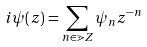<formula> <loc_0><loc_0><loc_500><loc_500>i \psi ( z ) = \sum _ { n \in \mathbb { m } { Z } } \psi _ { n } z ^ { - n }</formula> 